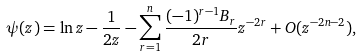<formula> <loc_0><loc_0><loc_500><loc_500>\psi ( z ) = \ln z - \frac { 1 } { 2 z } - \sum _ { r = 1 } ^ { n } \frac { ( - 1 ) ^ { r - 1 } B _ { r } } { 2 r } z ^ { - 2 r } + O ( z ^ { - 2 n - 2 } ) ,</formula> 